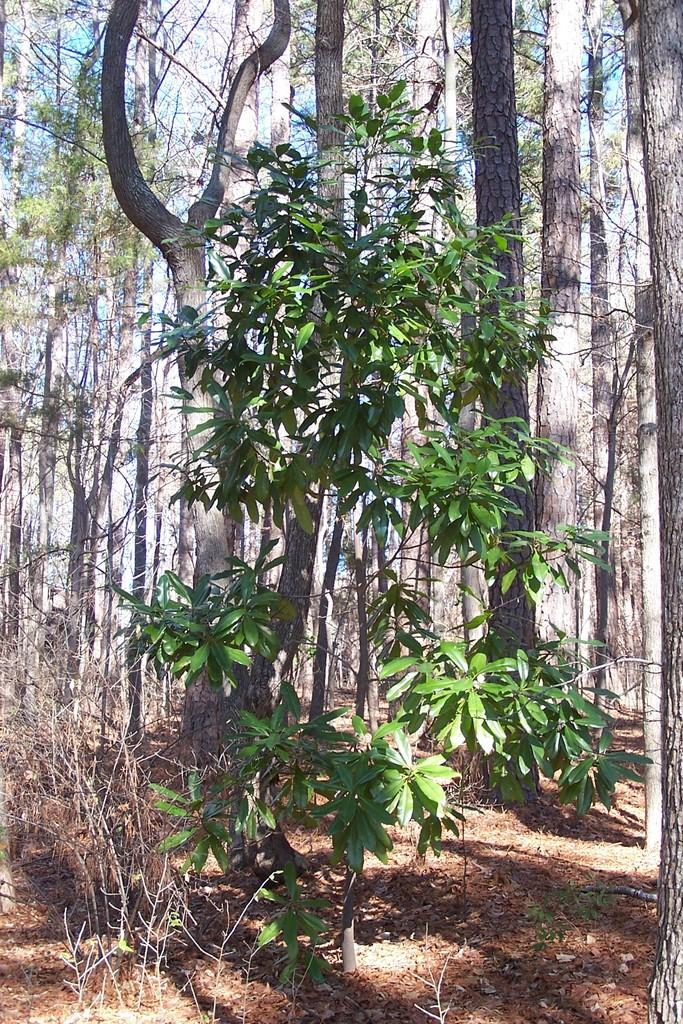What type of vegetation can be seen in the image? There are trees in the image. What part of the natural environment is visible in the background of the image? The sky is visible in the background of the image. Is there a bear climbing one of the trees in the image? There is no bear present in the image; only trees and the sky are visible. What type of trail can be seen in the image? There is no trail present in the image; it only features trees and the sky. 